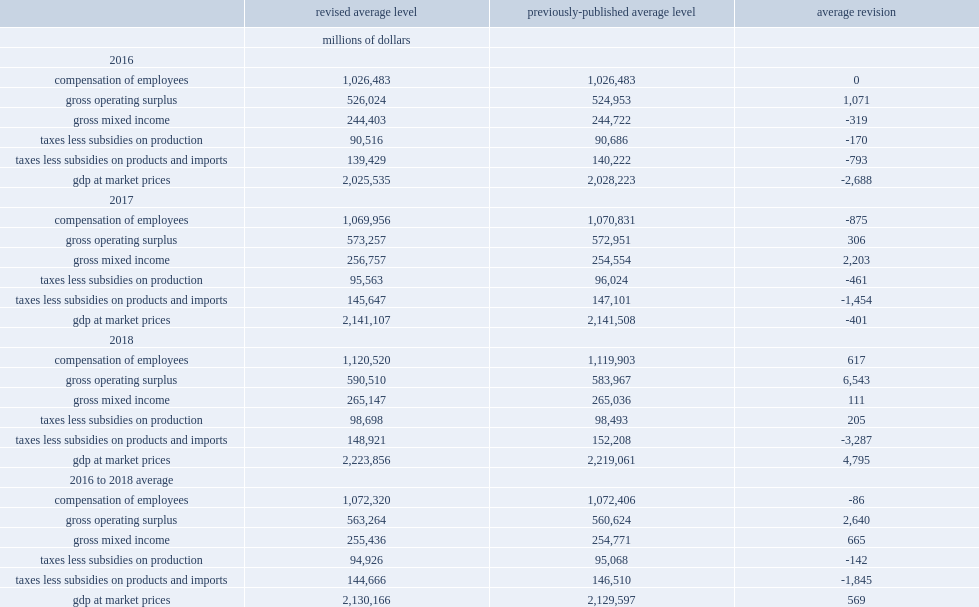In 2017, how many gross mixed taxes-less-subsidies on products and imports were revised down? 152208.0. 